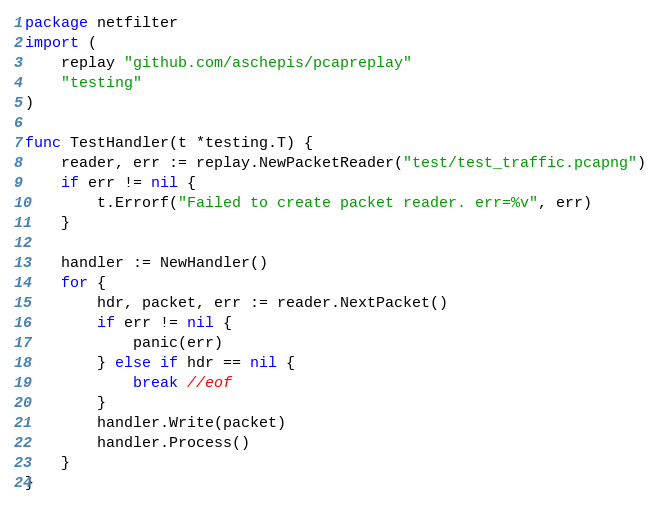Convert code to text. <code><loc_0><loc_0><loc_500><loc_500><_Go_>package netfilter
import (
	replay "github.com/aschepis/pcapreplay"
	"testing"
)

func TestHandler(t *testing.T) {
	reader, err := replay.NewPacketReader("test/test_traffic.pcapng")
	if err != nil {
		t.Errorf("Failed to create packet reader. err=%v", err)
	}

	handler := NewHandler()
	for {
		hdr, packet, err := reader.NextPacket()
		if err != nil {
			panic(err)
		} else if hdr == nil {
			break //eof
		}
		handler.Write(packet)
		handler.Process()
	}
}
</code> 